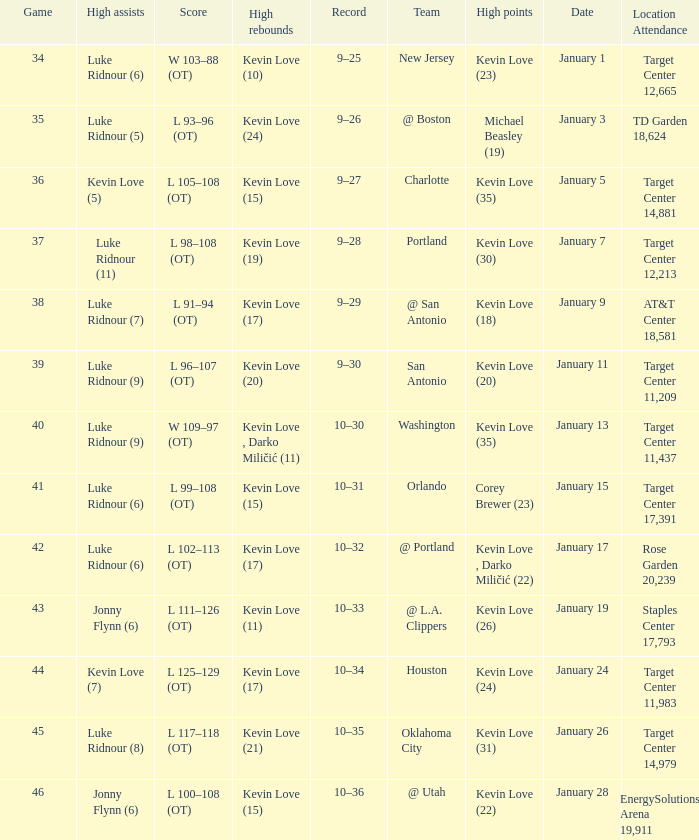How many times did kevin love (22) have the high points? 1.0. 